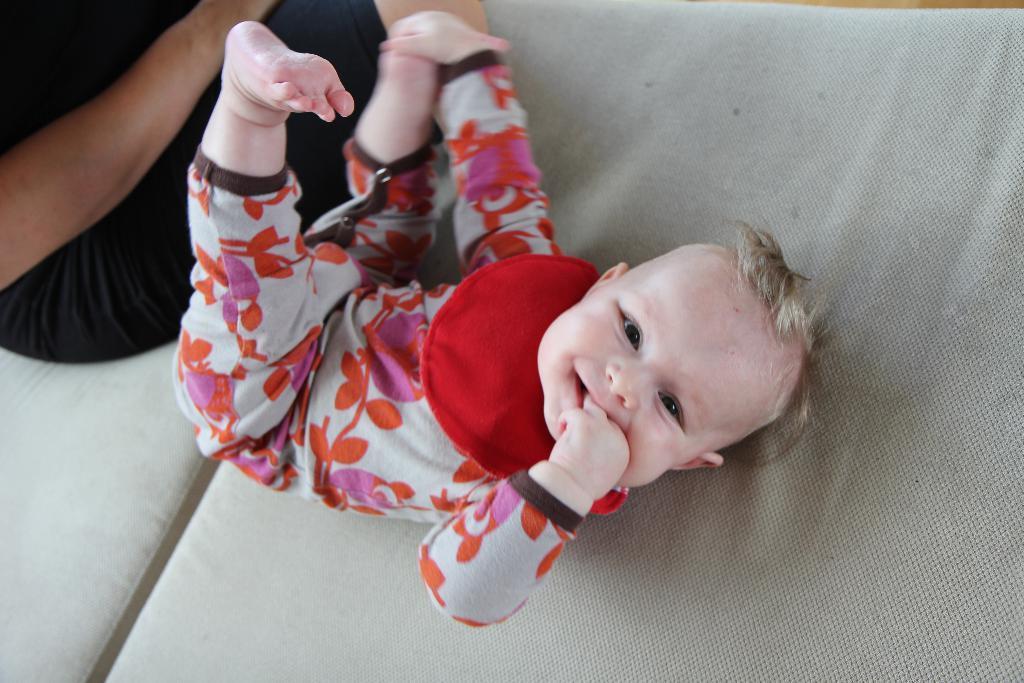Can you describe this image briefly? In the picture there is a baby lying on the bed, beside the baby there is a person sitting. 